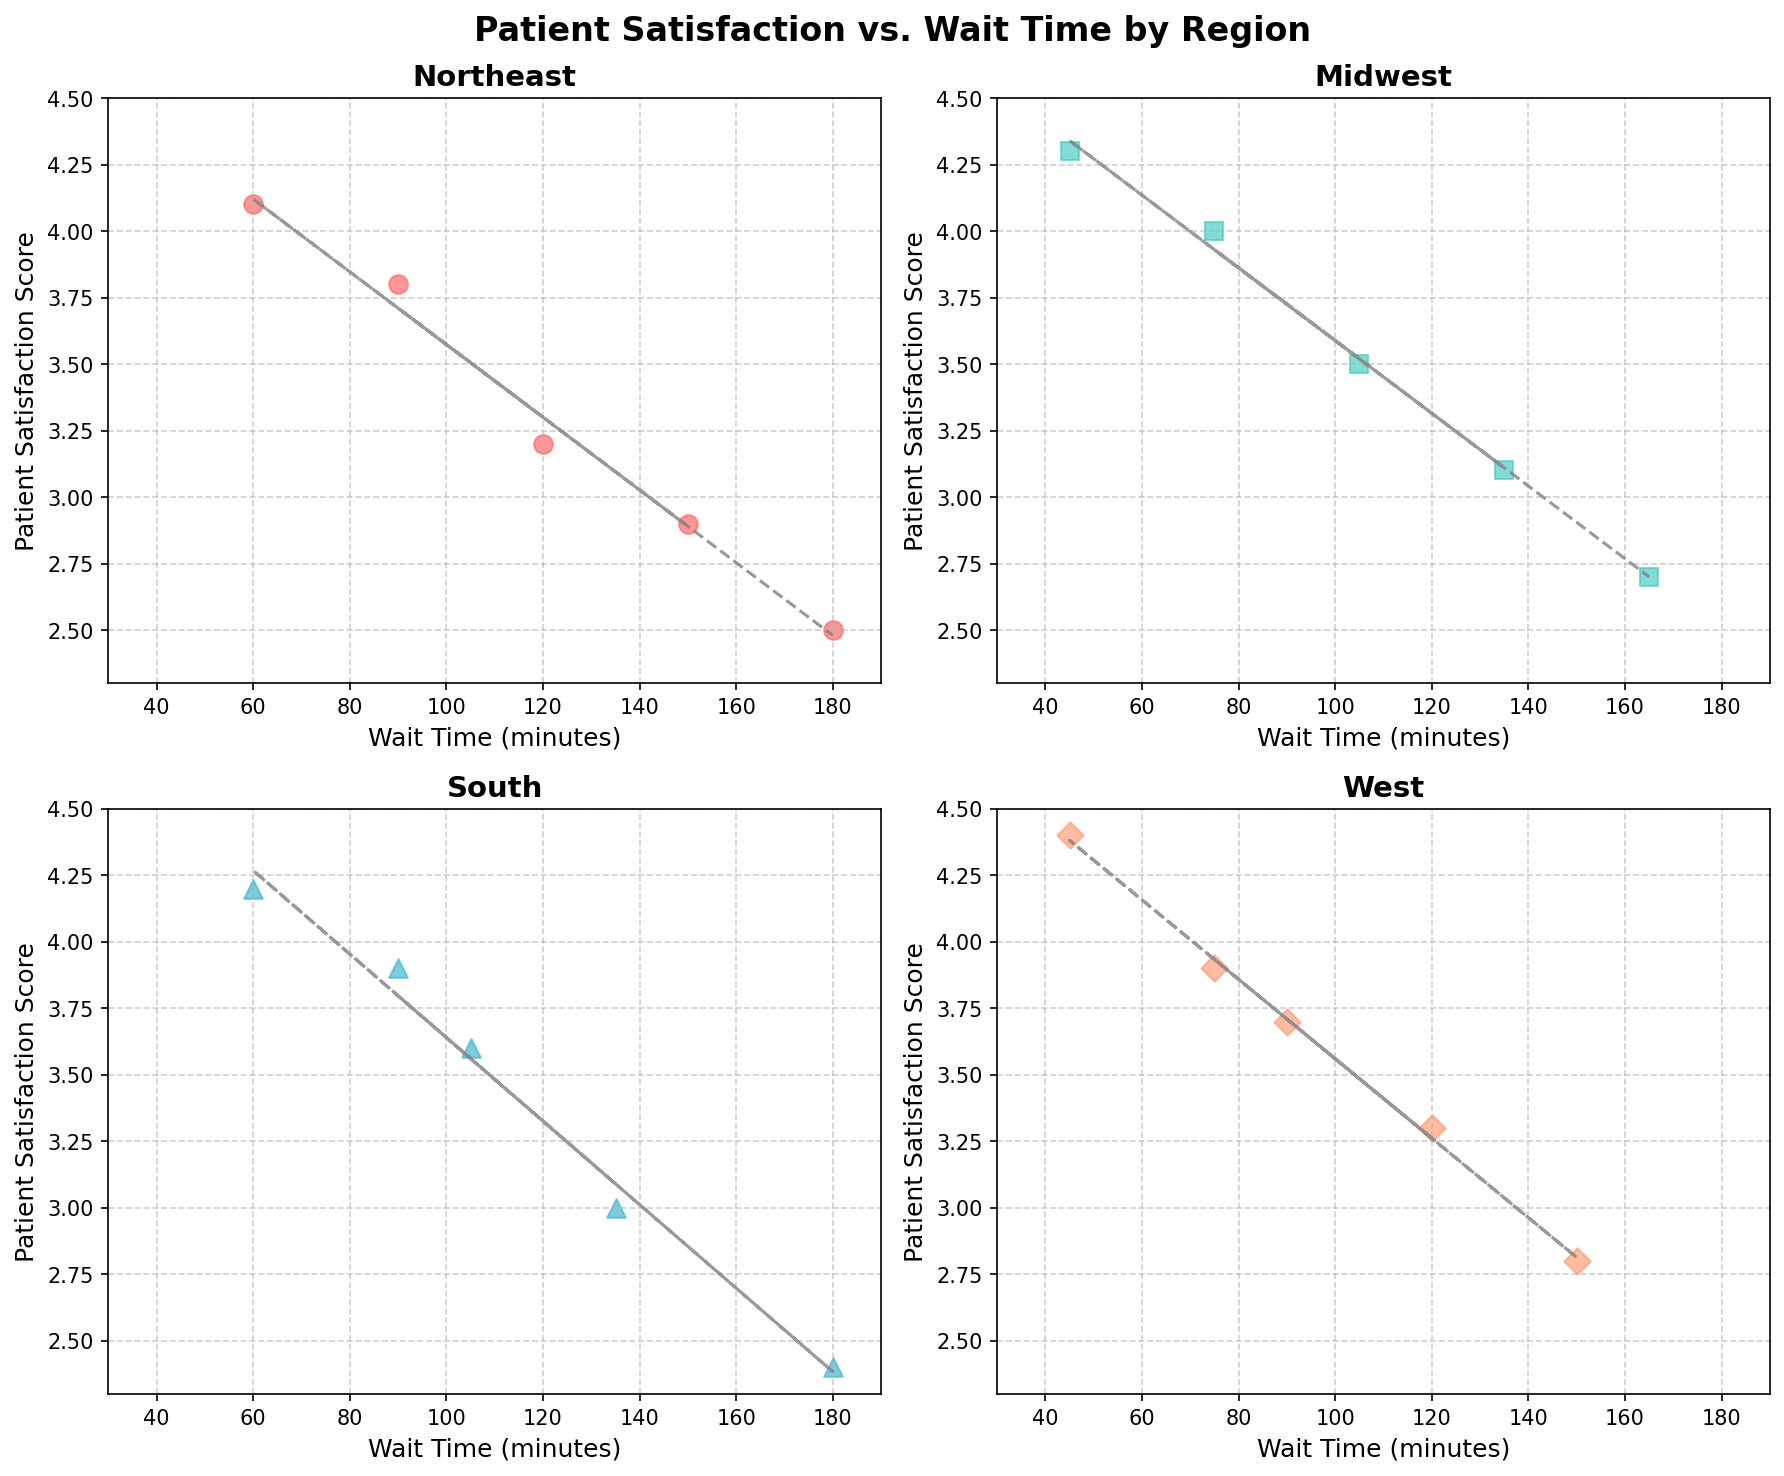How many regions are represented in the figure? The figure title mentions multiple regions, and each subplot has a distinct region name in its title: Northeast, Midwest, South, and West.
Answer: 4 How does patient satisfaction score trend with wait time in the Northeast region? By observing the scatter plot for the Northeast, we see that as the wait time increases, the patient satisfaction score decreases, which is confirmed by the downward sloping trend line.
Answer: Decreases Which region has the highest patient satisfaction score and what is the corresponding wait time? Look at the highest points in each subplot and compare their satisfaction scores. In the West region, the highest score is 4.4 at 45 minutes wait time.
Answer: West, 45 minutes What is the average wait time for patient satisfaction scores of 4.0 and above in the Midwest region? Identify data points in the Midwest subplot where satisfaction scores are 4.0 or higher. These points are at wait times of 75 and 45 minutes. Their average wait time is (75+45)/2 = 60 minutes.
Answer: 60 minutes In which region is the patient satisfaction score most likely to be above 4.0? Count and compare the number of points above 4.0 in each subplot. Both the Northeast and South have two points above 4.0, while the West has one, and the Midwest has two. However, the South region shows scores consistently closer to 4.0 and beyond.
Answer: South Which region shows the most variance in wait times according to the plot? Observe the range of wait times in each subplot. The Northeast region has a wide range from 60 to 180 minutes, indicating the highest variance.
Answer: Northeast Is there a region where the wait time does not exceed 150 minutes? Check the wait times in each subplot. The West region has the maximum wait time of 150 minutes.
Answer: West How does the Midwest region compare to the South in terms of average patient satisfaction score? Calculate the averages by adding all scores within each region and dividing by the count: Midwest (3.5+4.0+3.1+4.3+2.7)/5 = 3.52; South (3.0+4.2+2.4+3.6+3.9)/5 = 3.42.
Answer: Midwest has a higher average Which region has the lowest recorded patient satisfaction score and what is the corresponding wait time? Look for the lowest point in each subplot. The South region has the lowest satisfaction score of 2.4 at 180 minutes.
Answer: South, 180 minutes 